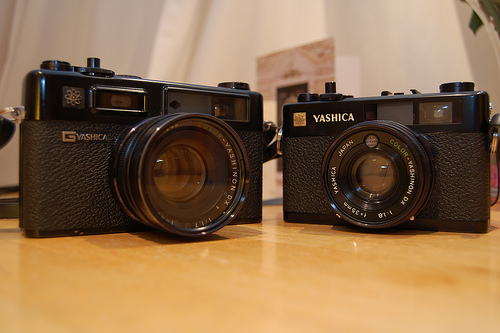<image>
Is there a camera to the left of the camera? No. The camera is not to the left of the camera. From this viewpoint, they have a different horizontal relationship. 